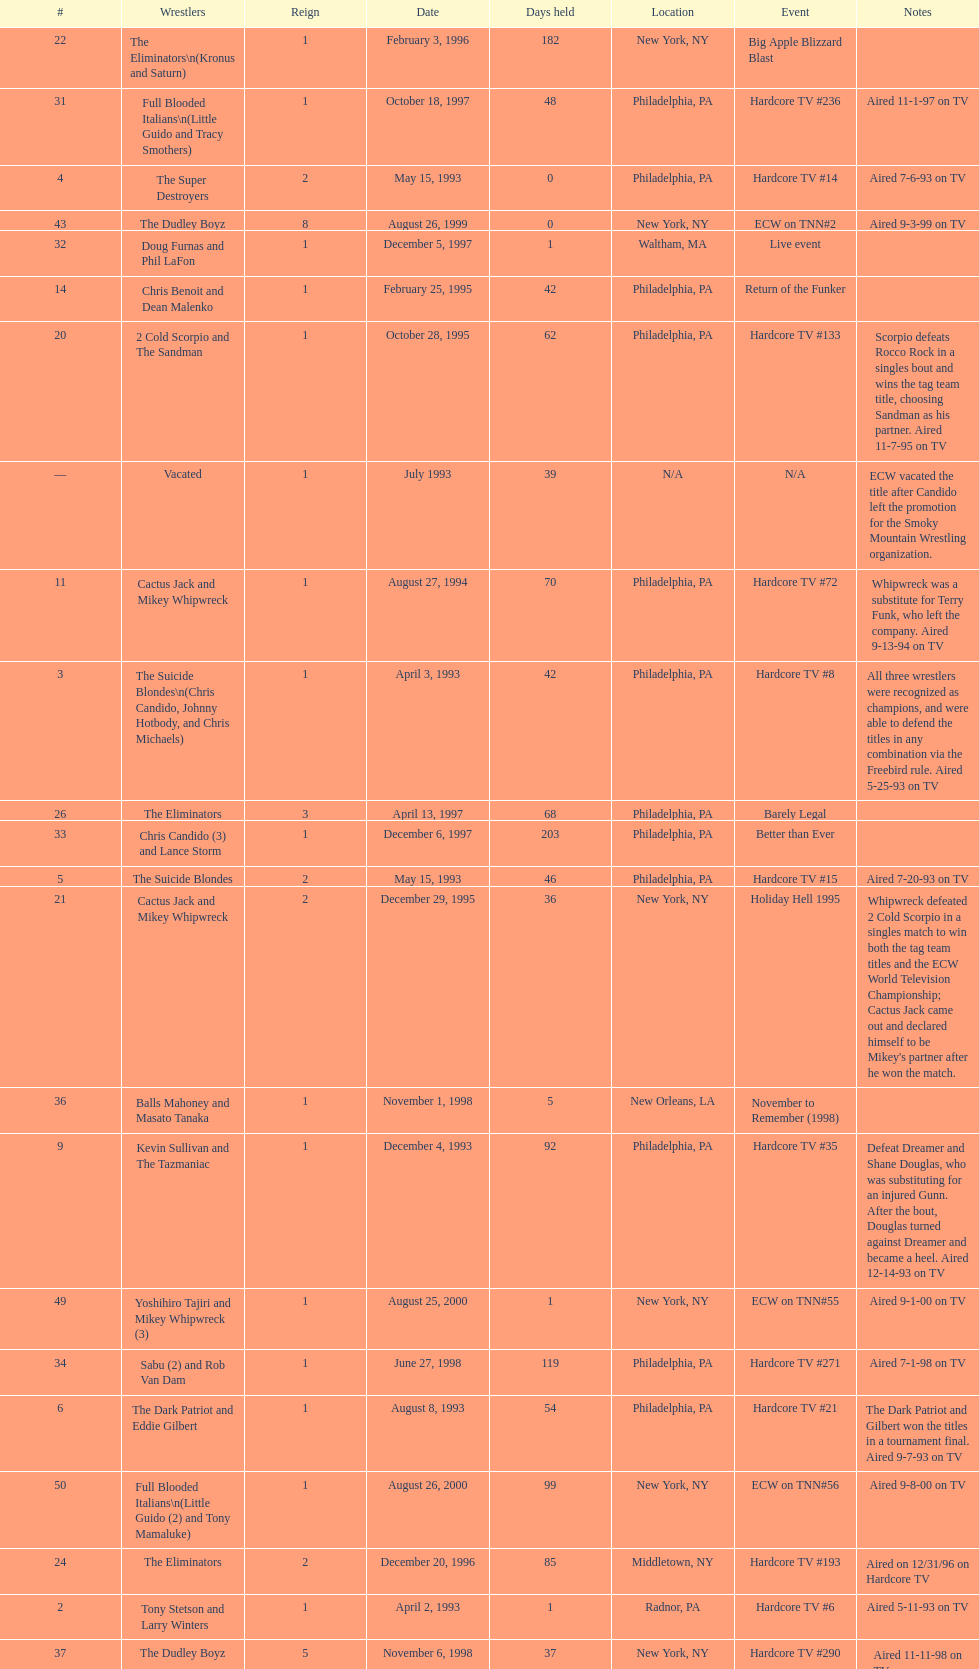Could you parse the entire table? {'header': ['#', 'Wrestlers', 'Reign', 'Date', 'Days held', 'Location', 'Event', 'Notes'], 'rows': [['22', 'The Eliminators\\n(Kronus and Saturn)', '1', 'February 3, 1996', '182', 'New York, NY', 'Big Apple Blizzard Blast', ''], ['31', 'Full Blooded Italians\\n(Little Guido and Tracy Smothers)', '1', 'October 18, 1997', '48', 'Philadelphia, PA', 'Hardcore TV #236', 'Aired 11-1-97 on TV'], ['4', 'The Super Destroyers', '2', 'May 15, 1993', '0', 'Philadelphia, PA', 'Hardcore TV #14', 'Aired 7-6-93 on TV'], ['43', 'The Dudley Boyz', '8', 'August 26, 1999', '0', 'New York, NY', 'ECW on TNN#2', 'Aired 9-3-99 on TV'], ['32', 'Doug Furnas and Phil LaFon', '1', 'December 5, 1997', '1', 'Waltham, MA', 'Live event', ''], ['14', 'Chris Benoit and Dean Malenko', '1', 'February 25, 1995', '42', 'Philadelphia, PA', 'Return of the Funker', ''], ['20', '2 Cold Scorpio and The Sandman', '1', 'October 28, 1995', '62', 'Philadelphia, PA', 'Hardcore TV #133', 'Scorpio defeats Rocco Rock in a singles bout and wins the tag team title, choosing Sandman as his partner. Aired 11-7-95 on TV'], ['—', 'Vacated', '1', 'July 1993', '39', 'N/A', 'N/A', 'ECW vacated the title after Candido left the promotion for the Smoky Mountain Wrestling organization.'], ['11', 'Cactus Jack and Mikey Whipwreck', '1', 'August 27, 1994', '70', 'Philadelphia, PA', 'Hardcore TV #72', 'Whipwreck was a substitute for Terry Funk, who left the company. Aired 9-13-94 on TV'], ['3', 'The Suicide Blondes\\n(Chris Candido, Johnny Hotbody, and Chris Michaels)', '1', 'April 3, 1993', '42', 'Philadelphia, PA', 'Hardcore TV #8', 'All three wrestlers were recognized as champions, and were able to defend the titles in any combination via the Freebird rule. Aired 5-25-93 on TV'], ['26', 'The Eliminators', '3', 'April 13, 1997', '68', 'Philadelphia, PA', 'Barely Legal', ''], ['33', 'Chris Candido (3) and Lance Storm', '1', 'December 6, 1997', '203', 'Philadelphia, PA', 'Better than Ever', ''], ['5', 'The Suicide Blondes', '2', 'May 15, 1993', '46', 'Philadelphia, PA', 'Hardcore TV #15', 'Aired 7-20-93 on TV'], ['21', 'Cactus Jack and Mikey Whipwreck', '2', 'December 29, 1995', '36', 'New York, NY', 'Holiday Hell 1995', "Whipwreck defeated 2 Cold Scorpio in a singles match to win both the tag team titles and the ECW World Television Championship; Cactus Jack came out and declared himself to be Mikey's partner after he won the match."], ['36', 'Balls Mahoney and Masato Tanaka', '1', 'November 1, 1998', '5', 'New Orleans, LA', 'November to Remember (1998)', ''], ['9', 'Kevin Sullivan and The Tazmaniac', '1', 'December 4, 1993', '92', 'Philadelphia, PA', 'Hardcore TV #35', 'Defeat Dreamer and Shane Douglas, who was substituting for an injured Gunn. After the bout, Douglas turned against Dreamer and became a heel. Aired 12-14-93 on TV'], ['49', 'Yoshihiro Tajiri and Mikey Whipwreck (3)', '1', 'August 25, 2000', '1', 'New York, NY', 'ECW on TNN#55', 'Aired 9-1-00 on TV'], ['34', 'Sabu (2) and Rob Van Dam', '1', 'June 27, 1998', '119', 'Philadelphia, PA', 'Hardcore TV #271', 'Aired 7-1-98 on TV'], ['6', 'The Dark Patriot and Eddie Gilbert', '1', 'August 8, 1993', '54', 'Philadelphia, PA', 'Hardcore TV #21', 'The Dark Patriot and Gilbert won the titles in a tournament final. Aired 9-7-93 on TV'], ['50', 'Full Blooded Italians\\n(Little Guido (2) and Tony Mamaluke)', '1', 'August 26, 2000', '99', 'New York, NY', 'ECW on TNN#56', 'Aired 9-8-00 on TV'], ['24', 'The Eliminators', '2', 'December 20, 1996', '85', 'Middletown, NY', 'Hardcore TV #193', 'Aired on 12/31/96 on Hardcore TV'], ['2', 'Tony Stetson and Larry Winters', '1', 'April 2, 1993', '1', 'Radnor, PA', 'Hardcore TV #6', 'Aired 5-11-93 on TV'], ['37', 'The Dudley Boyz', '5', 'November 6, 1998', '37', 'New York, NY', 'Hardcore TV #290', 'Aired 11-11-98 on TV'], ['13', 'Sabu and The Tazmaniac (2)', '1', 'February 4, 1995', '21', 'Philadelphia, PA', 'Double Tables', ''], ['44', 'Tommy Dreamer (2) and Raven (3)', '1', 'August 26, 1999', '136', 'New York, NY', 'ECW on TNN#2', 'Aired 9-3-99 on TV'], ['41', 'The Dudley Boyz', '7', 'August 13, 1999', '1', 'Cleveland, OH', 'Hardcore TV #330', 'Aired 8-20-99 on TV'], ['1', 'The Super Destroyers\\n(A.J. Petrucci and Doug Stahl)', '1', 'June 23, 1992', '283', 'Philadelphia, PA', 'Live event', 'Petrucci and Stahl won the titles in a tournament final.'], ['30', 'The Gangstanators\\n(Kronus (4) and New Jack (3))', '1', 'September 20, 1997', '28', 'Philadelphia, PA', 'As Good as it Gets', 'Aired 9-27-97 on TV'], ['25', 'The Dudley Boyz\\n(Buh Buh Ray Dudley and D-Von Dudley)', '1', 'March 15, 1997', '29', 'Philadelphia, PA', 'Hostile City Showdown', 'Aired 3/20/97 on Hardcore TV'], ['46', 'Tommy Dreamer (3) and Masato Tanaka (2)', '1', 'February 26, 2000', '7', 'Cincinnati, OH', 'Hardcore TV #358', 'Aired 3-7-00 on TV'], ['27', 'The Dudley Boyz', '2', 'June 20, 1997', '29', 'Waltham, MA', 'Hardcore TV #218', 'The Dudley Boyz defeated Kronus in a handicap match as a result of a sidelining injury sustained by Saturn. Aired 6-26-97 on TV'], ['8', 'Tommy Dreamer and Johnny Gunn', '1', 'November 13, 1993', '21', 'Philadelphia, PA', 'November to Remember (1993)', ''], ['39', 'The Dudley Boyz', '6', 'April 17, 1999', '92', 'Buffalo, NY', 'Hardcore TV #313', 'D-Von Dudley defeated Van Dam in a singles match to win the championship for his team. Aired 4-23-99 on TV'], ['51', 'Danny Doring and Roadkill', '1', 'December 3, 2000', '122', 'New York, NY', 'Massacre on 34th Street', "Doring and Roadkill's reign was the final one in the title's history."], ['29', 'The Dudley Boyz', '3', 'August 17, 1997', '95', 'Fort Lauderdale, FL', 'Hardcore Heaven (1997)', 'The Dudley Boyz won the championship via forfeit as a result of Mustapha Saed leaving the promotion before Hardcore Heaven took place.'], ['—', 'Vacated', '2', 'October 1, 1993', '0', 'Philadelphia, PA', 'Bloodfest: Part 1', 'ECW vacated the championships after The Dark Patriot and Eddie Gilbert left the organization.'], ['12', 'The Public Enemy', '2', 'November 5, 1994', '91', 'Philadelphia, PA', 'November to Remember (1994)', ''], ['19', 'The Public Enemy', '4', 'October 7, 1995', '21', 'Philadelphia, PA', 'Hardcore TV #131', 'Aired 10-24-95 on TV'], ['7', 'Johnny Hotbody (3) and Tony Stetson (2)', '1', 'October 1, 1993', '43', 'Philadelphia, PA', 'Bloodfest: Part 1', 'Hotbody and Stetson were awarded the titles by ECW.'], ['35', 'The Dudley Boyz', '4', 'October 24, 1998', '8', 'Cleveland, OH', 'Hardcore TV #288', 'Aired 10-28-98 on TV'], ['45', 'Impact Players\\n(Justin Credible and Lance Storm (2))', '1', 'January 9, 2000', '48', 'Birmingham, AL', 'Guilty as Charged (2000)', ''], ['—', 'Vacated', '3', 'April 22, 2000', '125', 'Philadelphia, PA', 'Live event', 'At CyberSlam, Justin Credible threw down the titles to become eligible for the ECW World Heavyweight Championship. Storm later left for World Championship Wrestling. As a result of the circumstances, Credible vacated the championship.'], ['38', 'Sabu (3) and Rob Van Dam', '2', 'December 13, 1998', '125', 'Tokyo, Japan', 'ECW/FMW Supershow II', 'Aired 12-16-98 on TV'], ['23', 'The Gangstas\\n(Mustapha Saed and New Jack)', '1', 'August 3, 1996', '139', 'Philadelphia, PA', 'Doctor Is In', ''], ['47', 'Mike Awesome and Raven (4)', '1', 'March 4, 2000', '8', 'Philadelphia, PA', 'ECW on TNN#29', 'Aired 3-10-00 on TV'], ['28', 'The Gangstas', '2', 'July 19, 1997', '29', 'Philadelphia, PA', 'Heat Wave 1997/Hardcore TV #222', 'Aired 7-24-97 on TV'], ['48', 'Impact Players\\n(Justin Credible and Lance Storm (3))', '2', 'March 12, 2000', '31', 'Danbury, CT', 'Living Dangerously', ''], ['17', 'The Pitbulls\\n(Pitbull #1 and Pitbull #2)', '1', 'September 16, 1995', '21', 'Philadelphia, PA', "Gangsta's Paradise", ''], ['10', 'The Public Enemy\\n(Johnny Grunge and Rocco Rock)', '1', 'March 6, 1994', '174', 'Philadelphia, PA', 'Hardcore TV #46', 'Aired 3-8-94 on TV'], ['15', 'The Public Enemy', '3', 'April 8, 1995', '83', 'Philadelphia, PA', 'Three Way Dance', 'Also def. Rick Steiner (who was a substitute for Sabu) and Taz in 3 way dance'], ['18', 'Raven and Stevie Richards', '2', 'October 7, 1995', '0', 'Philadelphia, PA', 'Hardcore TV #131', 'Aired 10-24-95 on TV'], ['42', 'Spike Dudley and Balls Mahoney (3)', '2', 'August 14, 1999', '12', 'Toledo, OH', 'Hardcore TV #331', 'Aired 8-27-99 on TV'], ['16', 'Raven and Stevie Richards', '1', 'June 30, 1995', '78', 'Jim Thorpe, PA', 'Hardcore TV #115', 'Aired 7-4-95 on TV'], ['40', 'Spike Dudley and Balls Mahoney (2)', '1', 'July 18, 1999', '26', 'Dayton, OH', 'Heat Wave (1999)', '']]} What is the total days held on # 1st? 283. 